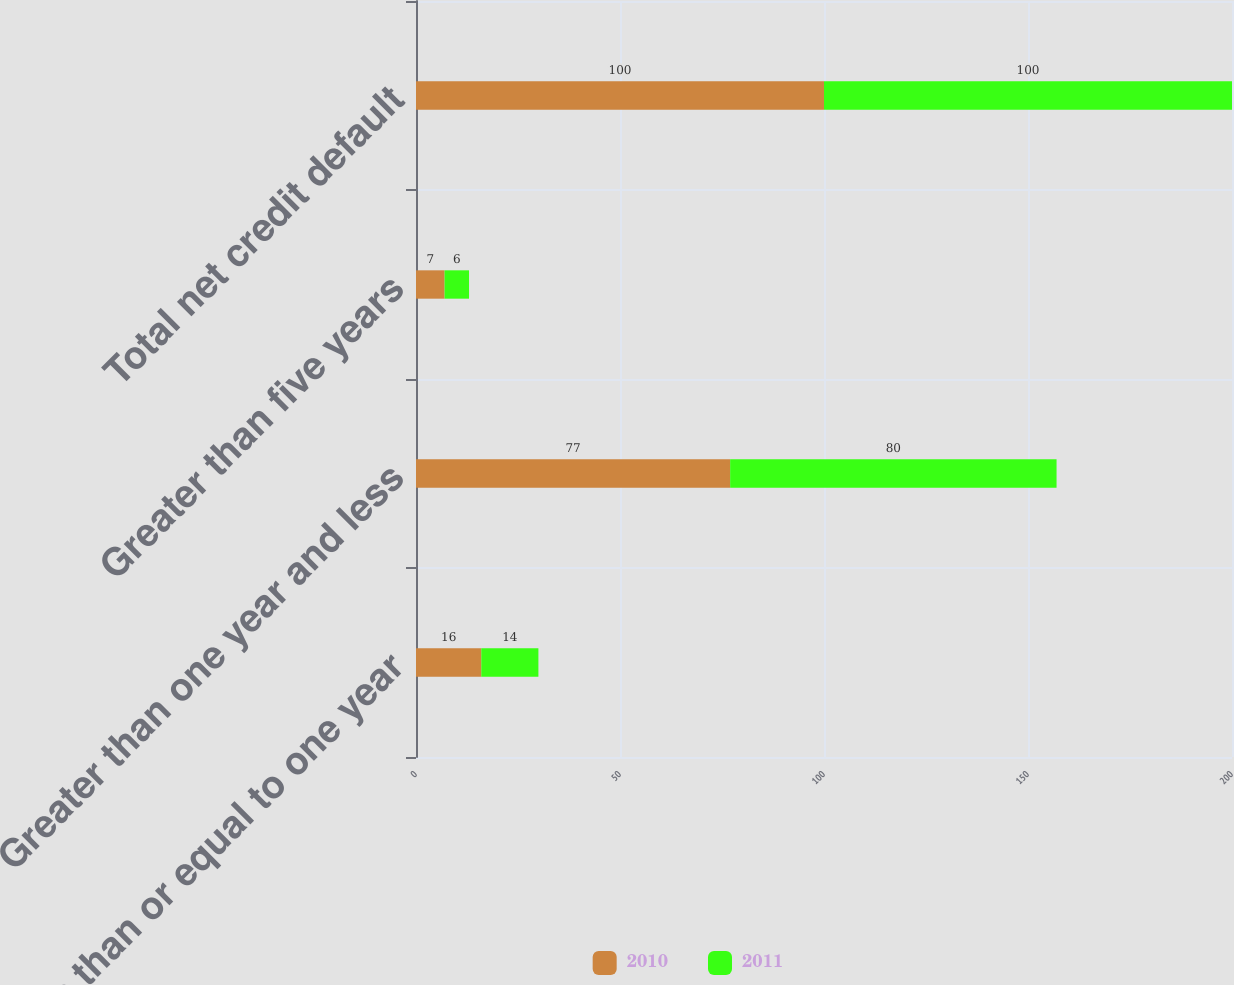<chart> <loc_0><loc_0><loc_500><loc_500><stacked_bar_chart><ecel><fcel>Less than or equal to one year<fcel>Greater than one year and less<fcel>Greater than five years<fcel>Total net credit default<nl><fcel>2010<fcel>16<fcel>77<fcel>7<fcel>100<nl><fcel>2011<fcel>14<fcel>80<fcel>6<fcel>100<nl></chart> 